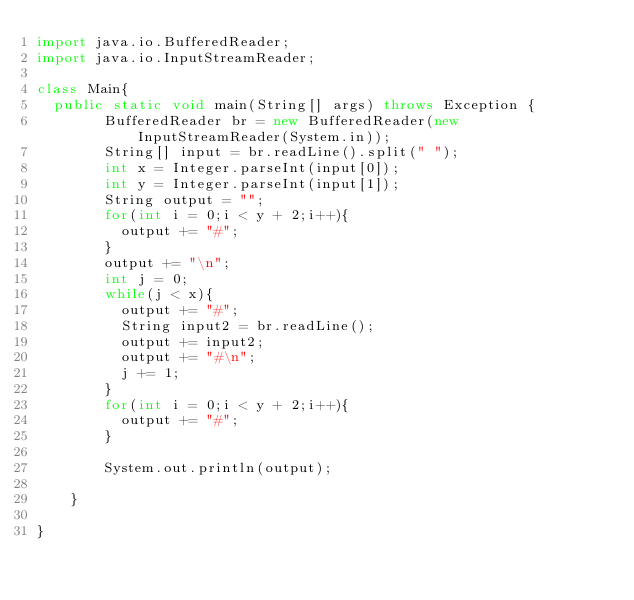Convert code to text. <code><loc_0><loc_0><loc_500><loc_500><_Java_>import java.io.BufferedReader;
import java.io.InputStreamReader;

class Main{
	public static void main(String[] args) throws Exception {
        BufferedReader br = new BufferedReader(new InputStreamReader(System.in));
        String[] input = br.readLine().split(" ");
        int x = Integer.parseInt(input[0]);
        int y = Integer.parseInt(input[1]);
        String output = "";
        for(int i = 0;i < y + 2;i++){
        	output += "#";
        }
        output += "\n";
        int j = 0;
        while(j < x){
        	output += "#";
        	String input2 = br.readLine();
        	output += input2;
        	output += "#\n";
        	j += 1;
        }
        for(int i = 0;i < y + 2;i++){
        	output += "#";
        }

        System.out.println(output);

    }

}</code> 